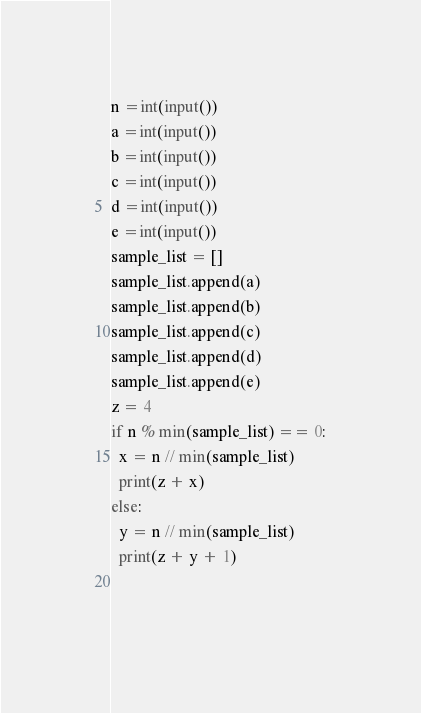Convert code to text. <code><loc_0><loc_0><loc_500><loc_500><_Python_>n =int(input())
a =int(input())
b =int(input())
c =int(input())
d =int(input())
e =int(input())
sample_list = []
sample_list.append(a)
sample_list.append(b)
sample_list.append(c)
sample_list.append(d)
sample_list.append(e)
z = 4
if n % min(sample_list) == 0:
  x = n // min(sample_list)
  print(z + x)
else:
  y = n // min(sample_list)
  print(z + y + 1)

    




</code> 